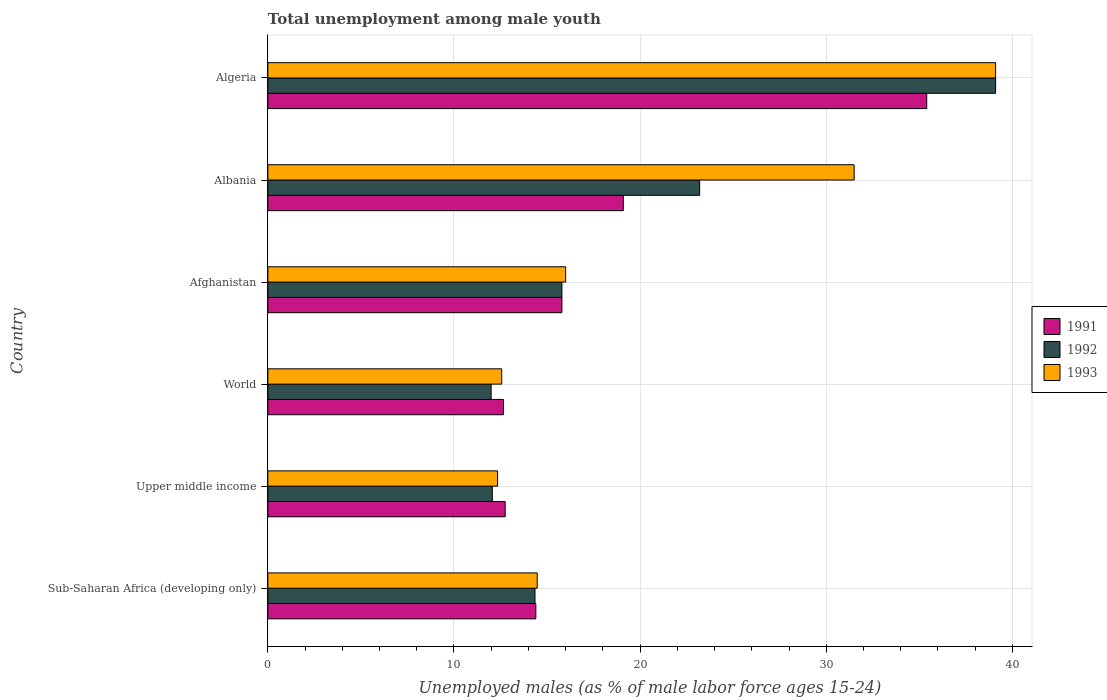How many different coloured bars are there?
Make the answer very short. 3. Are the number of bars per tick equal to the number of legend labels?
Keep it short and to the point. Yes. Are the number of bars on each tick of the Y-axis equal?
Offer a very short reply. Yes. What is the label of the 6th group of bars from the top?
Provide a succinct answer. Sub-Saharan Africa (developing only). What is the percentage of unemployed males in in 1991 in World?
Provide a short and direct response. 12.66. Across all countries, what is the maximum percentage of unemployed males in in 1991?
Your answer should be compact. 35.4. Across all countries, what is the minimum percentage of unemployed males in in 1993?
Your answer should be very brief. 12.34. In which country was the percentage of unemployed males in in 1992 maximum?
Ensure brevity in your answer.  Algeria. What is the total percentage of unemployed males in in 1993 in the graph?
Your answer should be very brief. 125.98. What is the difference between the percentage of unemployed males in in 1993 in Upper middle income and that in World?
Make the answer very short. -0.22. What is the difference between the percentage of unemployed males in in 1991 in Algeria and the percentage of unemployed males in in 1992 in Afghanistan?
Keep it short and to the point. 19.6. What is the average percentage of unemployed males in in 1991 per country?
Provide a succinct answer. 18.35. What is the difference between the percentage of unemployed males in in 1993 and percentage of unemployed males in in 1991 in Afghanistan?
Ensure brevity in your answer.  0.2. What is the ratio of the percentage of unemployed males in in 1992 in Albania to that in Upper middle income?
Give a very brief answer. 1.92. Is the percentage of unemployed males in in 1993 in Albania less than that in Upper middle income?
Your answer should be very brief. No. What is the difference between the highest and the second highest percentage of unemployed males in in 1991?
Make the answer very short. 16.3. What is the difference between the highest and the lowest percentage of unemployed males in in 1992?
Offer a terse response. 27.1. In how many countries, is the percentage of unemployed males in in 1991 greater than the average percentage of unemployed males in in 1991 taken over all countries?
Offer a terse response. 2. Is the sum of the percentage of unemployed males in in 1992 in Afghanistan and World greater than the maximum percentage of unemployed males in in 1993 across all countries?
Ensure brevity in your answer.  No. What does the 1st bar from the bottom in Afghanistan represents?
Offer a terse response. 1991. Is it the case that in every country, the sum of the percentage of unemployed males in in 1993 and percentage of unemployed males in in 1991 is greater than the percentage of unemployed males in in 1992?
Make the answer very short. Yes. How many bars are there?
Your answer should be very brief. 18. Are all the bars in the graph horizontal?
Your response must be concise. Yes. How many countries are there in the graph?
Ensure brevity in your answer.  6. What is the difference between two consecutive major ticks on the X-axis?
Provide a succinct answer. 10. Does the graph contain grids?
Your answer should be compact. Yes. Where does the legend appear in the graph?
Make the answer very short. Center right. How many legend labels are there?
Give a very brief answer. 3. How are the legend labels stacked?
Your answer should be compact. Vertical. What is the title of the graph?
Make the answer very short. Total unemployment among male youth. What is the label or title of the X-axis?
Give a very brief answer. Unemployed males (as % of male labor force ages 15-24). What is the Unemployed males (as % of male labor force ages 15-24) in 1991 in Sub-Saharan Africa (developing only)?
Your answer should be very brief. 14.4. What is the Unemployed males (as % of male labor force ages 15-24) in 1992 in Sub-Saharan Africa (developing only)?
Your response must be concise. 14.35. What is the Unemployed males (as % of male labor force ages 15-24) of 1993 in Sub-Saharan Africa (developing only)?
Your response must be concise. 14.47. What is the Unemployed males (as % of male labor force ages 15-24) in 1991 in Upper middle income?
Offer a very short reply. 12.75. What is the Unemployed males (as % of male labor force ages 15-24) of 1992 in Upper middle income?
Make the answer very short. 12.06. What is the Unemployed males (as % of male labor force ages 15-24) of 1993 in Upper middle income?
Your response must be concise. 12.34. What is the Unemployed males (as % of male labor force ages 15-24) of 1991 in World?
Give a very brief answer. 12.66. What is the Unemployed males (as % of male labor force ages 15-24) in 1992 in World?
Make the answer very short. 12. What is the Unemployed males (as % of male labor force ages 15-24) in 1993 in World?
Offer a terse response. 12.57. What is the Unemployed males (as % of male labor force ages 15-24) in 1991 in Afghanistan?
Keep it short and to the point. 15.8. What is the Unemployed males (as % of male labor force ages 15-24) of 1992 in Afghanistan?
Offer a very short reply. 15.8. What is the Unemployed males (as % of male labor force ages 15-24) in 1991 in Albania?
Offer a terse response. 19.1. What is the Unemployed males (as % of male labor force ages 15-24) of 1992 in Albania?
Provide a short and direct response. 23.2. What is the Unemployed males (as % of male labor force ages 15-24) in 1993 in Albania?
Your response must be concise. 31.5. What is the Unemployed males (as % of male labor force ages 15-24) in 1991 in Algeria?
Your answer should be very brief. 35.4. What is the Unemployed males (as % of male labor force ages 15-24) in 1992 in Algeria?
Provide a short and direct response. 39.1. What is the Unemployed males (as % of male labor force ages 15-24) in 1993 in Algeria?
Make the answer very short. 39.1. Across all countries, what is the maximum Unemployed males (as % of male labor force ages 15-24) in 1991?
Provide a short and direct response. 35.4. Across all countries, what is the maximum Unemployed males (as % of male labor force ages 15-24) in 1992?
Offer a very short reply. 39.1. Across all countries, what is the maximum Unemployed males (as % of male labor force ages 15-24) of 1993?
Keep it short and to the point. 39.1. Across all countries, what is the minimum Unemployed males (as % of male labor force ages 15-24) in 1991?
Provide a succinct answer. 12.66. Across all countries, what is the minimum Unemployed males (as % of male labor force ages 15-24) in 1992?
Ensure brevity in your answer.  12. Across all countries, what is the minimum Unemployed males (as % of male labor force ages 15-24) in 1993?
Your response must be concise. 12.34. What is the total Unemployed males (as % of male labor force ages 15-24) in 1991 in the graph?
Offer a terse response. 110.11. What is the total Unemployed males (as % of male labor force ages 15-24) in 1992 in the graph?
Offer a terse response. 116.51. What is the total Unemployed males (as % of male labor force ages 15-24) in 1993 in the graph?
Offer a very short reply. 125.98. What is the difference between the Unemployed males (as % of male labor force ages 15-24) in 1991 in Sub-Saharan Africa (developing only) and that in Upper middle income?
Make the answer very short. 1.65. What is the difference between the Unemployed males (as % of male labor force ages 15-24) in 1992 in Sub-Saharan Africa (developing only) and that in Upper middle income?
Your answer should be very brief. 2.29. What is the difference between the Unemployed males (as % of male labor force ages 15-24) in 1993 in Sub-Saharan Africa (developing only) and that in Upper middle income?
Offer a terse response. 2.13. What is the difference between the Unemployed males (as % of male labor force ages 15-24) in 1991 in Sub-Saharan Africa (developing only) and that in World?
Your answer should be compact. 1.74. What is the difference between the Unemployed males (as % of male labor force ages 15-24) of 1992 in Sub-Saharan Africa (developing only) and that in World?
Give a very brief answer. 2.36. What is the difference between the Unemployed males (as % of male labor force ages 15-24) in 1993 in Sub-Saharan Africa (developing only) and that in World?
Keep it short and to the point. 1.91. What is the difference between the Unemployed males (as % of male labor force ages 15-24) of 1991 in Sub-Saharan Africa (developing only) and that in Afghanistan?
Your answer should be compact. -1.4. What is the difference between the Unemployed males (as % of male labor force ages 15-24) of 1992 in Sub-Saharan Africa (developing only) and that in Afghanistan?
Keep it short and to the point. -1.45. What is the difference between the Unemployed males (as % of male labor force ages 15-24) of 1993 in Sub-Saharan Africa (developing only) and that in Afghanistan?
Give a very brief answer. -1.53. What is the difference between the Unemployed males (as % of male labor force ages 15-24) of 1991 in Sub-Saharan Africa (developing only) and that in Albania?
Keep it short and to the point. -4.7. What is the difference between the Unemployed males (as % of male labor force ages 15-24) of 1992 in Sub-Saharan Africa (developing only) and that in Albania?
Provide a succinct answer. -8.85. What is the difference between the Unemployed males (as % of male labor force ages 15-24) in 1993 in Sub-Saharan Africa (developing only) and that in Albania?
Your response must be concise. -17.03. What is the difference between the Unemployed males (as % of male labor force ages 15-24) of 1991 in Sub-Saharan Africa (developing only) and that in Algeria?
Your answer should be compact. -21. What is the difference between the Unemployed males (as % of male labor force ages 15-24) of 1992 in Sub-Saharan Africa (developing only) and that in Algeria?
Give a very brief answer. -24.75. What is the difference between the Unemployed males (as % of male labor force ages 15-24) of 1993 in Sub-Saharan Africa (developing only) and that in Algeria?
Offer a very short reply. -24.63. What is the difference between the Unemployed males (as % of male labor force ages 15-24) in 1991 in Upper middle income and that in World?
Your answer should be compact. 0.09. What is the difference between the Unemployed males (as % of male labor force ages 15-24) of 1992 in Upper middle income and that in World?
Give a very brief answer. 0.06. What is the difference between the Unemployed males (as % of male labor force ages 15-24) of 1993 in Upper middle income and that in World?
Provide a succinct answer. -0.22. What is the difference between the Unemployed males (as % of male labor force ages 15-24) of 1991 in Upper middle income and that in Afghanistan?
Your response must be concise. -3.05. What is the difference between the Unemployed males (as % of male labor force ages 15-24) in 1992 in Upper middle income and that in Afghanistan?
Keep it short and to the point. -3.74. What is the difference between the Unemployed males (as % of male labor force ages 15-24) in 1993 in Upper middle income and that in Afghanistan?
Give a very brief answer. -3.66. What is the difference between the Unemployed males (as % of male labor force ages 15-24) in 1991 in Upper middle income and that in Albania?
Your response must be concise. -6.35. What is the difference between the Unemployed males (as % of male labor force ages 15-24) of 1992 in Upper middle income and that in Albania?
Ensure brevity in your answer.  -11.14. What is the difference between the Unemployed males (as % of male labor force ages 15-24) in 1993 in Upper middle income and that in Albania?
Ensure brevity in your answer.  -19.16. What is the difference between the Unemployed males (as % of male labor force ages 15-24) of 1991 in Upper middle income and that in Algeria?
Your answer should be very brief. -22.65. What is the difference between the Unemployed males (as % of male labor force ages 15-24) of 1992 in Upper middle income and that in Algeria?
Give a very brief answer. -27.04. What is the difference between the Unemployed males (as % of male labor force ages 15-24) of 1993 in Upper middle income and that in Algeria?
Offer a terse response. -26.76. What is the difference between the Unemployed males (as % of male labor force ages 15-24) of 1991 in World and that in Afghanistan?
Your answer should be very brief. -3.14. What is the difference between the Unemployed males (as % of male labor force ages 15-24) of 1992 in World and that in Afghanistan?
Ensure brevity in your answer.  -3.8. What is the difference between the Unemployed males (as % of male labor force ages 15-24) of 1993 in World and that in Afghanistan?
Provide a succinct answer. -3.43. What is the difference between the Unemployed males (as % of male labor force ages 15-24) of 1991 in World and that in Albania?
Keep it short and to the point. -6.44. What is the difference between the Unemployed males (as % of male labor force ages 15-24) in 1992 in World and that in Albania?
Your answer should be very brief. -11.2. What is the difference between the Unemployed males (as % of male labor force ages 15-24) of 1993 in World and that in Albania?
Offer a very short reply. -18.93. What is the difference between the Unemployed males (as % of male labor force ages 15-24) of 1991 in World and that in Algeria?
Your answer should be compact. -22.74. What is the difference between the Unemployed males (as % of male labor force ages 15-24) of 1992 in World and that in Algeria?
Offer a very short reply. -27.1. What is the difference between the Unemployed males (as % of male labor force ages 15-24) of 1993 in World and that in Algeria?
Make the answer very short. -26.53. What is the difference between the Unemployed males (as % of male labor force ages 15-24) of 1993 in Afghanistan and that in Albania?
Your answer should be compact. -15.5. What is the difference between the Unemployed males (as % of male labor force ages 15-24) of 1991 in Afghanistan and that in Algeria?
Keep it short and to the point. -19.6. What is the difference between the Unemployed males (as % of male labor force ages 15-24) in 1992 in Afghanistan and that in Algeria?
Your response must be concise. -23.3. What is the difference between the Unemployed males (as % of male labor force ages 15-24) of 1993 in Afghanistan and that in Algeria?
Your answer should be very brief. -23.1. What is the difference between the Unemployed males (as % of male labor force ages 15-24) in 1991 in Albania and that in Algeria?
Provide a short and direct response. -16.3. What is the difference between the Unemployed males (as % of male labor force ages 15-24) of 1992 in Albania and that in Algeria?
Ensure brevity in your answer.  -15.9. What is the difference between the Unemployed males (as % of male labor force ages 15-24) of 1991 in Sub-Saharan Africa (developing only) and the Unemployed males (as % of male labor force ages 15-24) of 1992 in Upper middle income?
Offer a terse response. 2.34. What is the difference between the Unemployed males (as % of male labor force ages 15-24) of 1991 in Sub-Saharan Africa (developing only) and the Unemployed males (as % of male labor force ages 15-24) of 1993 in Upper middle income?
Offer a very short reply. 2.06. What is the difference between the Unemployed males (as % of male labor force ages 15-24) of 1992 in Sub-Saharan Africa (developing only) and the Unemployed males (as % of male labor force ages 15-24) of 1993 in Upper middle income?
Provide a short and direct response. 2.01. What is the difference between the Unemployed males (as % of male labor force ages 15-24) in 1991 in Sub-Saharan Africa (developing only) and the Unemployed males (as % of male labor force ages 15-24) in 1992 in World?
Your answer should be very brief. 2.4. What is the difference between the Unemployed males (as % of male labor force ages 15-24) of 1991 in Sub-Saharan Africa (developing only) and the Unemployed males (as % of male labor force ages 15-24) of 1993 in World?
Offer a very short reply. 1.83. What is the difference between the Unemployed males (as % of male labor force ages 15-24) in 1992 in Sub-Saharan Africa (developing only) and the Unemployed males (as % of male labor force ages 15-24) in 1993 in World?
Offer a terse response. 1.79. What is the difference between the Unemployed males (as % of male labor force ages 15-24) in 1991 in Sub-Saharan Africa (developing only) and the Unemployed males (as % of male labor force ages 15-24) in 1992 in Afghanistan?
Ensure brevity in your answer.  -1.4. What is the difference between the Unemployed males (as % of male labor force ages 15-24) of 1991 in Sub-Saharan Africa (developing only) and the Unemployed males (as % of male labor force ages 15-24) of 1993 in Afghanistan?
Your answer should be very brief. -1.6. What is the difference between the Unemployed males (as % of male labor force ages 15-24) in 1992 in Sub-Saharan Africa (developing only) and the Unemployed males (as % of male labor force ages 15-24) in 1993 in Afghanistan?
Make the answer very short. -1.65. What is the difference between the Unemployed males (as % of male labor force ages 15-24) of 1991 in Sub-Saharan Africa (developing only) and the Unemployed males (as % of male labor force ages 15-24) of 1992 in Albania?
Provide a succinct answer. -8.8. What is the difference between the Unemployed males (as % of male labor force ages 15-24) in 1991 in Sub-Saharan Africa (developing only) and the Unemployed males (as % of male labor force ages 15-24) in 1993 in Albania?
Offer a very short reply. -17.1. What is the difference between the Unemployed males (as % of male labor force ages 15-24) in 1992 in Sub-Saharan Africa (developing only) and the Unemployed males (as % of male labor force ages 15-24) in 1993 in Albania?
Ensure brevity in your answer.  -17.15. What is the difference between the Unemployed males (as % of male labor force ages 15-24) in 1991 in Sub-Saharan Africa (developing only) and the Unemployed males (as % of male labor force ages 15-24) in 1992 in Algeria?
Give a very brief answer. -24.7. What is the difference between the Unemployed males (as % of male labor force ages 15-24) of 1991 in Sub-Saharan Africa (developing only) and the Unemployed males (as % of male labor force ages 15-24) of 1993 in Algeria?
Make the answer very short. -24.7. What is the difference between the Unemployed males (as % of male labor force ages 15-24) of 1992 in Sub-Saharan Africa (developing only) and the Unemployed males (as % of male labor force ages 15-24) of 1993 in Algeria?
Offer a terse response. -24.75. What is the difference between the Unemployed males (as % of male labor force ages 15-24) in 1991 in Upper middle income and the Unemployed males (as % of male labor force ages 15-24) in 1992 in World?
Provide a succinct answer. 0.75. What is the difference between the Unemployed males (as % of male labor force ages 15-24) of 1991 in Upper middle income and the Unemployed males (as % of male labor force ages 15-24) of 1993 in World?
Make the answer very short. 0.19. What is the difference between the Unemployed males (as % of male labor force ages 15-24) of 1992 in Upper middle income and the Unemployed males (as % of male labor force ages 15-24) of 1993 in World?
Offer a terse response. -0.51. What is the difference between the Unemployed males (as % of male labor force ages 15-24) in 1991 in Upper middle income and the Unemployed males (as % of male labor force ages 15-24) in 1992 in Afghanistan?
Your answer should be very brief. -3.05. What is the difference between the Unemployed males (as % of male labor force ages 15-24) of 1991 in Upper middle income and the Unemployed males (as % of male labor force ages 15-24) of 1993 in Afghanistan?
Provide a succinct answer. -3.25. What is the difference between the Unemployed males (as % of male labor force ages 15-24) in 1992 in Upper middle income and the Unemployed males (as % of male labor force ages 15-24) in 1993 in Afghanistan?
Provide a succinct answer. -3.94. What is the difference between the Unemployed males (as % of male labor force ages 15-24) of 1991 in Upper middle income and the Unemployed males (as % of male labor force ages 15-24) of 1992 in Albania?
Your answer should be compact. -10.45. What is the difference between the Unemployed males (as % of male labor force ages 15-24) of 1991 in Upper middle income and the Unemployed males (as % of male labor force ages 15-24) of 1993 in Albania?
Offer a terse response. -18.75. What is the difference between the Unemployed males (as % of male labor force ages 15-24) of 1992 in Upper middle income and the Unemployed males (as % of male labor force ages 15-24) of 1993 in Albania?
Your answer should be compact. -19.44. What is the difference between the Unemployed males (as % of male labor force ages 15-24) of 1991 in Upper middle income and the Unemployed males (as % of male labor force ages 15-24) of 1992 in Algeria?
Give a very brief answer. -26.35. What is the difference between the Unemployed males (as % of male labor force ages 15-24) of 1991 in Upper middle income and the Unemployed males (as % of male labor force ages 15-24) of 1993 in Algeria?
Give a very brief answer. -26.35. What is the difference between the Unemployed males (as % of male labor force ages 15-24) of 1992 in Upper middle income and the Unemployed males (as % of male labor force ages 15-24) of 1993 in Algeria?
Your response must be concise. -27.04. What is the difference between the Unemployed males (as % of male labor force ages 15-24) of 1991 in World and the Unemployed males (as % of male labor force ages 15-24) of 1992 in Afghanistan?
Your answer should be compact. -3.14. What is the difference between the Unemployed males (as % of male labor force ages 15-24) of 1991 in World and the Unemployed males (as % of male labor force ages 15-24) of 1993 in Afghanistan?
Ensure brevity in your answer.  -3.34. What is the difference between the Unemployed males (as % of male labor force ages 15-24) of 1992 in World and the Unemployed males (as % of male labor force ages 15-24) of 1993 in Afghanistan?
Your answer should be compact. -4. What is the difference between the Unemployed males (as % of male labor force ages 15-24) in 1991 in World and the Unemployed males (as % of male labor force ages 15-24) in 1992 in Albania?
Keep it short and to the point. -10.54. What is the difference between the Unemployed males (as % of male labor force ages 15-24) of 1991 in World and the Unemployed males (as % of male labor force ages 15-24) of 1993 in Albania?
Your response must be concise. -18.84. What is the difference between the Unemployed males (as % of male labor force ages 15-24) in 1992 in World and the Unemployed males (as % of male labor force ages 15-24) in 1993 in Albania?
Give a very brief answer. -19.5. What is the difference between the Unemployed males (as % of male labor force ages 15-24) of 1991 in World and the Unemployed males (as % of male labor force ages 15-24) of 1992 in Algeria?
Offer a very short reply. -26.44. What is the difference between the Unemployed males (as % of male labor force ages 15-24) in 1991 in World and the Unemployed males (as % of male labor force ages 15-24) in 1993 in Algeria?
Keep it short and to the point. -26.44. What is the difference between the Unemployed males (as % of male labor force ages 15-24) in 1992 in World and the Unemployed males (as % of male labor force ages 15-24) in 1993 in Algeria?
Keep it short and to the point. -27.1. What is the difference between the Unemployed males (as % of male labor force ages 15-24) of 1991 in Afghanistan and the Unemployed males (as % of male labor force ages 15-24) of 1993 in Albania?
Give a very brief answer. -15.7. What is the difference between the Unemployed males (as % of male labor force ages 15-24) in 1992 in Afghanistan and the Unemployed males (as % of male labor force ages 15-24) in 1993 in Albania?
Ensure brevity in your answer.  -15.7. What is the difference between the Unemployed males (as % of male labor force ages 15-24) of 1991 in Afghanistan and the Unemployed males (as % of male labor force ages 15-24) of 1992 in Algeria?
Provide a succinct answer. -23.3. What is the difference between the Unemployed males (as % of male labor force ages 15-24) in 1991 in Afghanistan and the Unemployed males (as % of male labor force ages 15-24) in 1993 in Algeria?
Offer a very short reply. -23.3. What is the difference between the Unemployed males (as % of male labor force ages 15-24) of 1992 in Afghanistan and the Unemployed males (as % of male labor force ages 15-24) of 1993 in Algeria?
Offer a very short reply. -23.3. What is the difference between the Unemployed males (as % of male labor force ages 15-24) in 1992 in Albania and the Unemployed males (as % of male labor force ages 15-24) in 1993 in Algeria?
Offer a very short reply. -15.9. What is the average Unemployed males (as % of male labor force ages 15-24) of 1991 per country?
Your answer should be very brief. 18.35. What is the average Unemployed males (as % of male labor force ages 15-24) in 1992 per country?
Provide a short and direct response. 19.42. What is the average Unemployed males (as % of male labor force ages 15-24) of 1993 per country?
Keep it short and to the point. 21. What is the difference between the Unemployed males (as % of male labor force ages 15-24) in 1991 and Unemployed males (as % of male labor force ages 15-24) in 1992 in Sub-Saharan Africa (developing only)?
Offer a very short reply. 0.05. What is the difference between the Unemployed males (as % of male labor force ages 15-24) of 1991 and Unemployed males (as % of male labor force ages 15-24) of 1993 in Sub-Saharan Africa (developing only)?
Make the answer very short. -0.07. What is the difference between the Unemployed males (as % of male labor force ages 15-24) of 1992 and Unemployed males (as % of male labor force ages 15-24) of 1993 in Sub-Saharan Africa (developing only)?
Your answer should be very brief. -0.12. What is the difference between the Unemployed males (as % of male labor force ages 15-24) of 1991 and Unemployed males (as % of male labor force ages 15-24) of 1992 in Upper middle income?
Provide a succinct answer. 0.69. What is the difference between the Unemployed males (as % of male labor force ages 15-24) in 1991 and Unemployed males (as % of male labor force ages 15-24) in 1993 in Upper middle income?
Offer a terse response. 0.41. What is the difference between the Unemployed males (as % of male labor force ages 15-24) in 1992 and Unemployed males (as % of male labor force ages 15-24) in 1993 in Upper middle income?
Provide a short and direct response. -0.28. What is the difference between the Unemployed males (as % of male labor force ages 15-24) of 1991 and Unemployed males (as % of male labor force ages 15-24) of 1992 in World?
Your answer should be very brief. 0.66. What is the difference between the Unemployed males (as % of male labor force ages 15-24) of 1991 and Unemployed males (as % of male labor force ages 15-24) of 1993 in World?
Ensure brevity in your answer.  0.09. What is the difference between the Unemployed males (as % of male labor force ages 15-24) of 1992 and Unemployed males (as % of male labor force ages 15-24) of 1993 in World?
Offer a very short reply. -0.57. What is the difference between the Unemployed males (as % of male labor force ages 15-24) of 1991 and Unemployed males (as % of male labor force ages 15-24) of 1993 in Afghanistan?
Your answer should be compact. -0.2. What is the difference between the Unemployed males (as % of male labor force ages 15-24) in 1992 and Unemployed males (as % of male labor force ages 15-24) in 1993 in Afghanistan?
Ensure brevity in your answer.  -0.2. What is the difference between the Unemployed males (as % of male labor force ages 15-24) of 1991 and Unemployed males (as % of male labor force ages 15-24) of 1992 in Albania?
Provide a succinct answer. -4.1. What is the difference between the Unemployed males (as % of male labor force ages 15-24) of 1992 and Unemployed males (as % of male labor force ages 15-24) of 1993 in Albania?
Ensure brevity in your answer.  -8.3. What is the difference between the Unemployed males (as % of male labor force ages 15-24) of 1991 and Unemployed males (as % of male labor force ages 15-24) of 1992 in Algeria?
Ensure brevity in your answer.  -3.7. What is the difference between the Unemployed males (as % of male labor force ages 15-24) in 1991 and Unemployed males (as % of male labor force ages 15-24) in 1993 in Algeria?
Your answer should be very brief. -3.7. What is the difference between the Unemployed males (as % of male labor force ages 15-24) in 1992 and Unemployed males (as % of male labor force ages 15-24) in 1993 in Algeria?
Your response must be concise. 0. What is the ratio of the Unemployed males (as % of male labor force ages 15-24) in 1991 in Sub-Saharan Africa (developing only) to that in Upper middle income?
Your answer should be very brief. 1.13. What is the ratio of the Unemployed males (as % of male labor force ages 15-24) in 1992 in Sub-Saharan Africa (developing only) to that in Upper middle income?
Provide a succinct answer. 1.19. What is the ratio of the Unemployed males (as % of male labor force ages 15-24) in 1993 in Sub-Saharan Africa (developing only) to that in Upper middle income?
Your response must be concise. 1.17. What is the ratio of the Unemployed males (as % of male labor force ages 15-24) of 1991 in Sub-Saharan Africa (developing only) to that in World?
Your response must be concise. 1.14. What is the ratio of the Unemployed males (as % of male labor force ages 15-24) of 1992 in Sub-Saharan Africa (developing only) to that in World?
Provide a short and direct response. 1.2. What is the ratio of the Unemployed males (as % of male labor force ages 15-24) of 1993 in Sub-Saharan Africa (developing only) to that in World?
Provide a succinct answer. 1.15. What is the ratio of the Unemployed males (as % of male labor force ages 15-24) in 1991 in Sub-Saharan Africa (developing only) to that in Afghanistan?
Keep it short and to the point. 0.91. What is the ratio of the Unemployed males (as % of male labor force ages 15-24) in 1992 in Sub-Saharan Africa (developing only) to that in Afghanistan?
Your response must be concise. 0.91. What is the ratio of the Unemployed males (as % of male labor force ages 15-24) in 1993 in Sub-Saharan Africa (developing only) to that in Afghanistan?
Keep it short and to the point. 0.9. What is the ratio of the Unemployed males (as % of male labor force ages 15-24) of 1991 in Sub-Saharan Africa (developing only) to that in Albania?
Ensure brevity in your answer.  0.75. What is the ratio of the Unemployed males (as % of male labor force ages 15-24) in 1992 in Sub-Saharan Africa (developing only) to that in Albania?
Provide a short and direct response. 0.62. What is the ratio of the Unemployed males (as % of male labor force ages 15-24) in 1993 in Sub-Saharan Africa (developing only) to that in Albania?
Your response must be concise. 0.46. What is the ratio of the Unemployed males (as % of male labor force ages 15-24) of 1991 in Sub-Saharan Africa (developing only) to that in Algeria?
Provide a short and direct response. 0.41. What is the ratio of the Unemployed males (as % of male labor force ages 15-24) in 1992 in Sub-Saharan Africa (developing only) to that in Algeria?
Make the answer very short. 0.37. What is the ratio of the Unemployed males (as % of male labor force ages 15-24) of 1993 in Sub-Saharan Africa (developing only) to that in Algeria?
Ensure brevity in your answer.  0.37. What is the ratio of the Unemployed males (as % of male labor force ages 15-24) in 1992 in Upper middle income to that in World?
Your answer should be very brief. 1.01. What is the ratio of the Unemployed males (as % of male labor force ages 15-24) in 1993 in Upper middle income to that in World?
Your answer should be compact. 0.98. What is the ratio of the Unemployed males (as % of male labor force ages 15-24) in 1991 in Upper middle income to that in Afghanistan?
Your answer should be compact. 0.81. What is the ratio of the Unemployed males (as % of male labor force ages 15-24) of 1992 in Upper middle income to that in Afghanistan?
Offer a terse response. 0.76. What is the ratio of the Unemployed males (as % of male labor force ages 15-24) of 1993 in Upper middle income to that in Afghanistan?
Make the answer very short. 0.77. What is the ratio of the Unemployed males (as % of male labor force ages 15-24) of 1991 in Upper middle income to that in Albania?
Keep it short and to the point. 0.67. What is the ratio of the Unemployed males (as % of male labor force ages 15-24) in 1992 in Upper middle income to that in Albania?
Your response must be concise. 0.52. What is the ratio of the Unemployed males (as % of male labor force ages 15-24) of 1993 in Upper middle income to that in Albania?
Provide a succinct answer. 0.39. What is the ratio of the Unemployed males (as % of male labor force ages 15-24) of 1991 in Upper middle income to that in Algeria?
Provide a succinct answer. 0.36. What is the ratio of the Unemployed males (as % of male labor force ages 15-24) of 1992 in Upper middle income to that in Algeria?
Ensure brevity in your answer.  0.31. What is the ratio of the Unemployed males (as % of male labor force ages 15-24) of 1993 in Upper middle income to that in Algeria?
Keep it short and to the point. 0.32. What is the ratio of the Unemployed males (as % of male labor force ages 15-24) in 1991 in World to that in Afghanistan?
Give a very brief answer. 0.8. What is the ratio of the Unemployed males (as % of male labor force ages 15-24) of 1992 in World to that in Afghanistan?
Provide a succinct answer. 0.76. What is the ratio of the Unemployed males (as % of male labor force ages 15-24) of 1993 in World to that in Afghanistan?
Offer a terse response. 0.79. What is the ratio of the Unemployed males (as % of male labor force ages 15-24) in 1991 in World to that in Albania?
Your response must be concise. 0.66. What is the ratio of the Unemployed males (as % of male labor force ages 15-24) in 1992 in World to that in Albania?
Provide a succinct answer. 0.52. What is the ratio of the Unemployed males (as % of male labor force ages 15-24) in 1993 in World to that in Albania?
Your response must be concise. 0.4. What is the ratio of the Unemployed males (as % of male labor force ages 15-24) of 1991 in World to that in Algeria?
Offer a terse response. 0.36. What is the ratio of the Unemployed males (as % of male labor force ages 15-24) in 1992 in World to that in Algeria?
Your response must be concise. 0.31. What is the ratio of the Unemployed males (as % of male labor force ages 15-24) of 1993 in World to that in Algeria?
Your response must be concise. 0.32. What is the ratio of the Unemployed males (as % of male labor force ages 15-24) in 1991 in Afghanistan to that in Albania?
Offer a very short reply. 0.83. What is the ratio of the Unemployed males (as % of male labor force ages 15-24) in 1992 in Afghanistan to that in Albania?
Offer a terse response. 0.68. What is the ratio of the Unemployed males (as % of male labor force ages 15-24) of 1993 in Afghanistan to that in Albania?
Provide a succinct answer. 0.51. What is the ratio of the Unemployed males (as % of male labor force ages 15-24) in 1991 in Afghanistan to that in Algeria?
Give a very brief answer. 0.45. What is the ratio of the Unemployed males (as % of male labor force ages 15-24) of 1992 in Afghanistan to that in Algeria?
Keep it short and to the point. 0.4. What is the ratio of the Unemployed males (as % of male labor force ages 15-24) in 1993 in Afghanistan to that in Algeria?
Ensure brevity in your answer.  0.41. What is the ratio of the Unemployed males (as % of male labor force ages 15-24) in 1991 in Albania to that in Algeria?
Offer a very short reply. 0.54. What is the ratio of the Unemployed males (as % of male labor force ages 15-24) of 1992 in Albania to that in Algeria?
Offer a very short reply. 0.59. What is the ratio of the Unemployed males (as % of male labor force ages 15-24) of 1993 in Albania to that in Algeria?
Keep it short and to the point. 0.81. What is the difference between the highest and the second highest Unemployed males (as % of male labor force ages 15-24) of 1991?
Keep it short and to the point. 16.3. What is the difference between the highest and the second highest Unemployed males (as % of male labor force ages 15-24) of 1992?
Offer a terse response. 15.9. What is the difference between the highest and the second highest Unemployed males (as % of male labor force ages 15-24) of 1993?
Offer a very short reply. 7.6. What is the difference between the highest and the lowest Unemployed males (as % of male labor force ages 15-24) in 1991?
Ensure brevity in your answer.  22.74. What is the difference between the highest and the lowest Unemployed males (as % of male labor force ages 15-24) in 1992?
Keep it short and to the point. 27.1. What is the difference between the highest and the lowest Unemployed males (as % of male labor force ages 15-24) of 1993?
Keep it short and to the point. 26.76. 